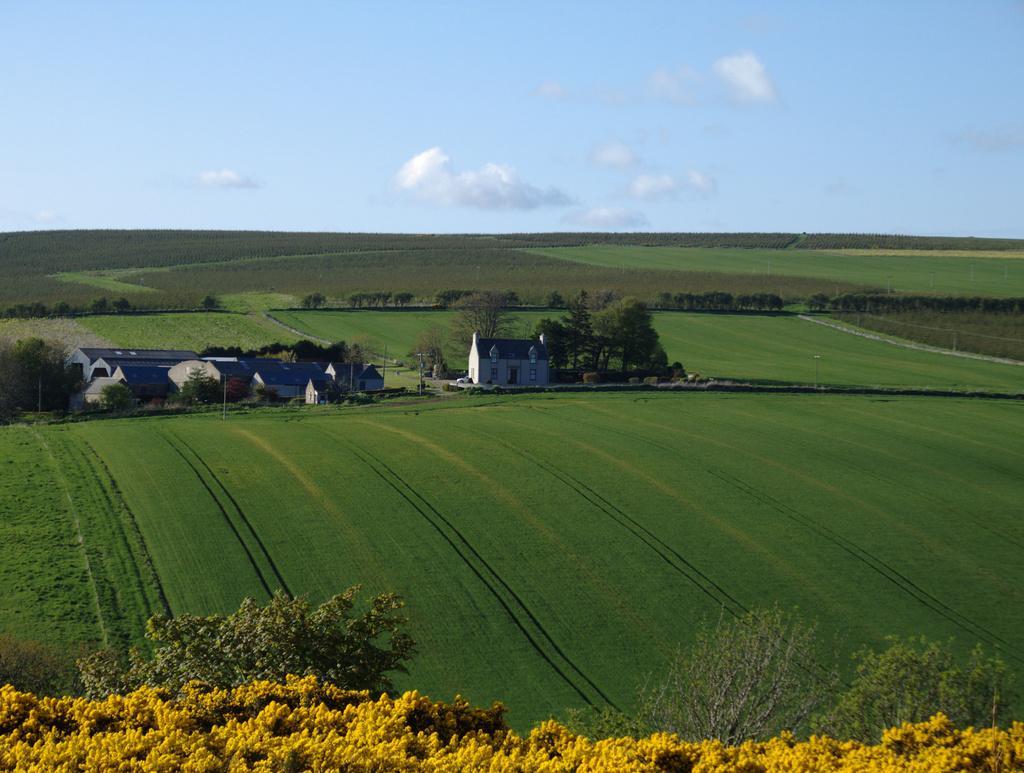Can you describe this image briefly? In this image in the front there are flowers and plants. In the center there are houses and there are plants and there is grass. In the background there is grass and the sky is cloudy. 